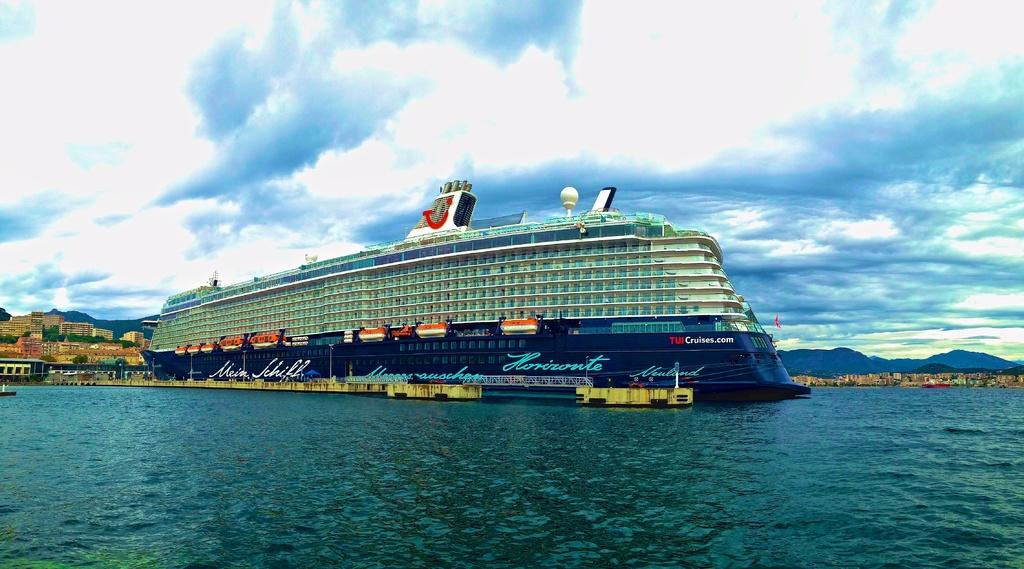What type of vehicle is present in the image? There is a ship in the image. Are there any other similar vehicles in the image? Yes, there are boats in the image. How are the ship and boats positioned in the image? The ship and boats are above the water. What can be seen in the background of the image? There are buildings, poles, trees, hills, and the sky visible in the background of the image. What is the condition of the sky in the image? The sky is visible in the background of the image, and there are clouds present. Can you hear the dogs barking in the image? There are no dogs present in the image, so it is not possible to hear them barking. 